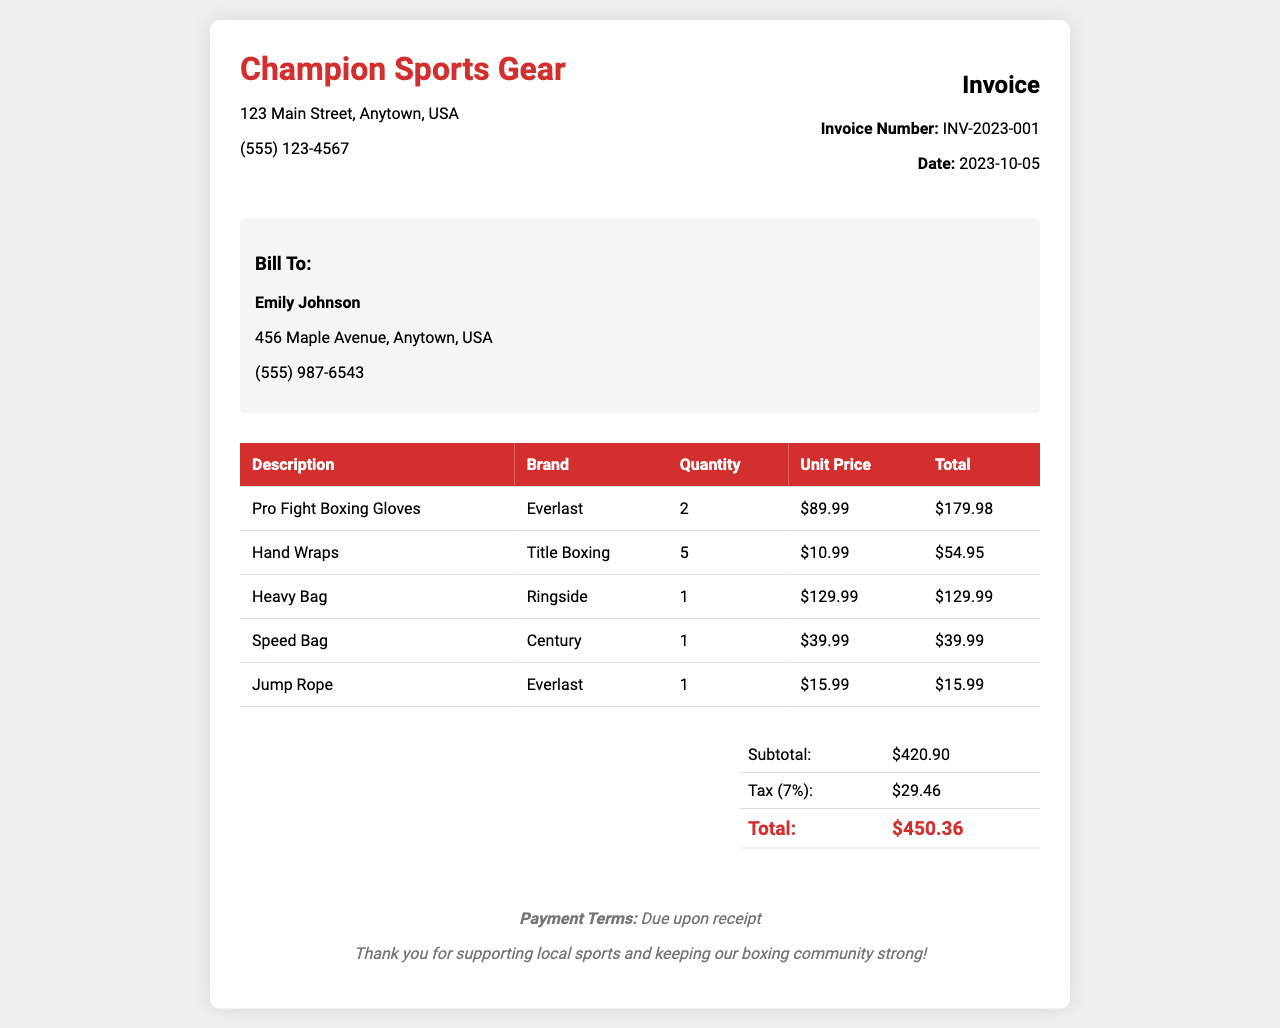What is the invoice number? The invoice number is mentioned in the invoice header section, identified as INV-2023-001.
Answer: INV-2023-001 Who is billed in the invoice? The "Bill To" section identifies the customer as Emily Johnson.
Answer: Emily Johnson What is the date of the invoice? The invoice date is shown in the invoice header as 2023-10-05.
Answer: 2023-10-05 What is the subtotal amount? The subtotal is provided in the summary section as $420.90.
Answer: $420.90 What are the total boxing gloves purchased? The table lists the quantity of Pro Fight Boxing Gloves as 2.
Answer: 2 What is the total amount after tax? The total amount is displayed at the end of the summary section, totaling $450.36.
Answer: $450.36 What brand are the hand wraps? The brand of the hand wraps listed in the invoice is Title Boxing.
Answer: Title Boxing How much tax is applied to the invoice? The tax amount is calculated in the summary as $29.46.
Answer: $29.46 What are the payment terms stated in the invoice? The payment terms are clearly stated in the footer as "Due upon receipt."
Answer: Due upon receipt 